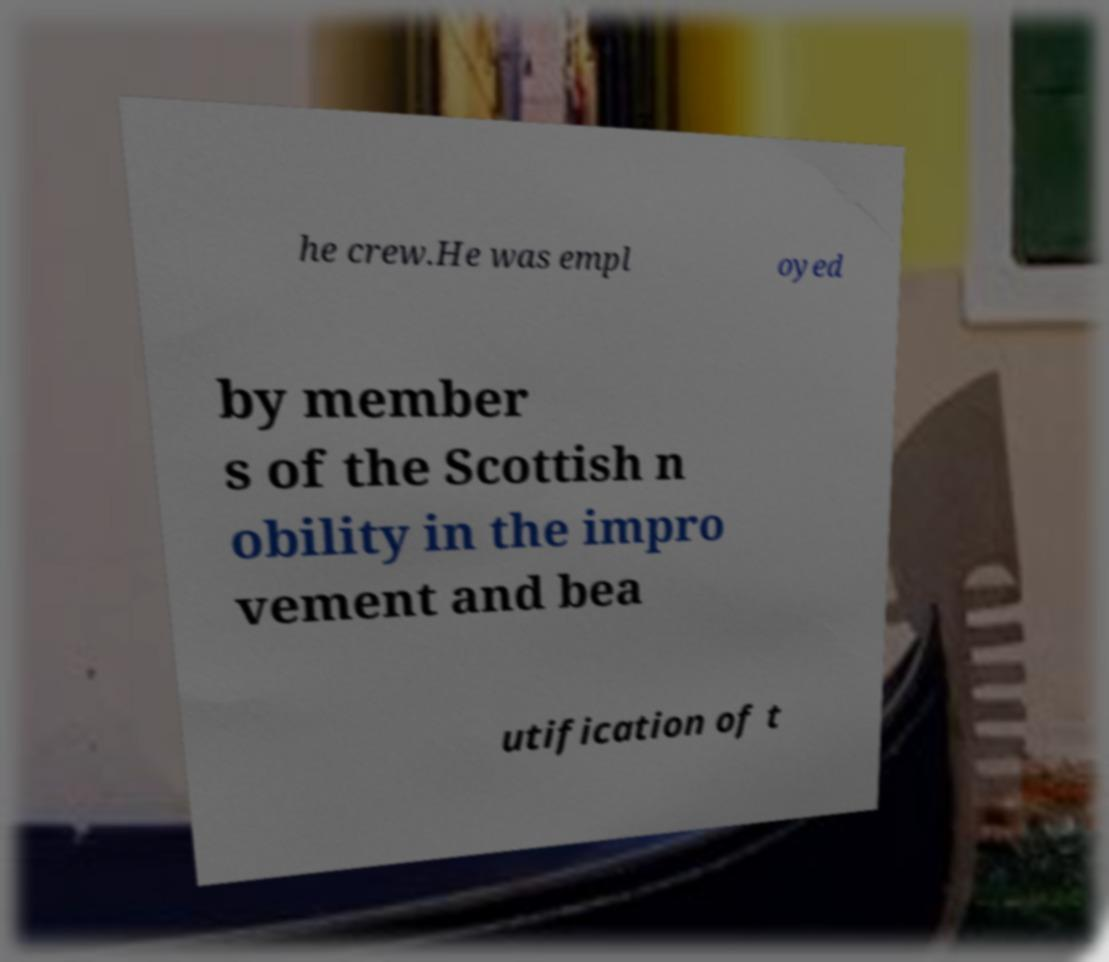I need the written content from this picture converted into text. Can you do that? he crew.He was empl oyed by member s of the Scottish n obility in the impro vement and bea utification of t 